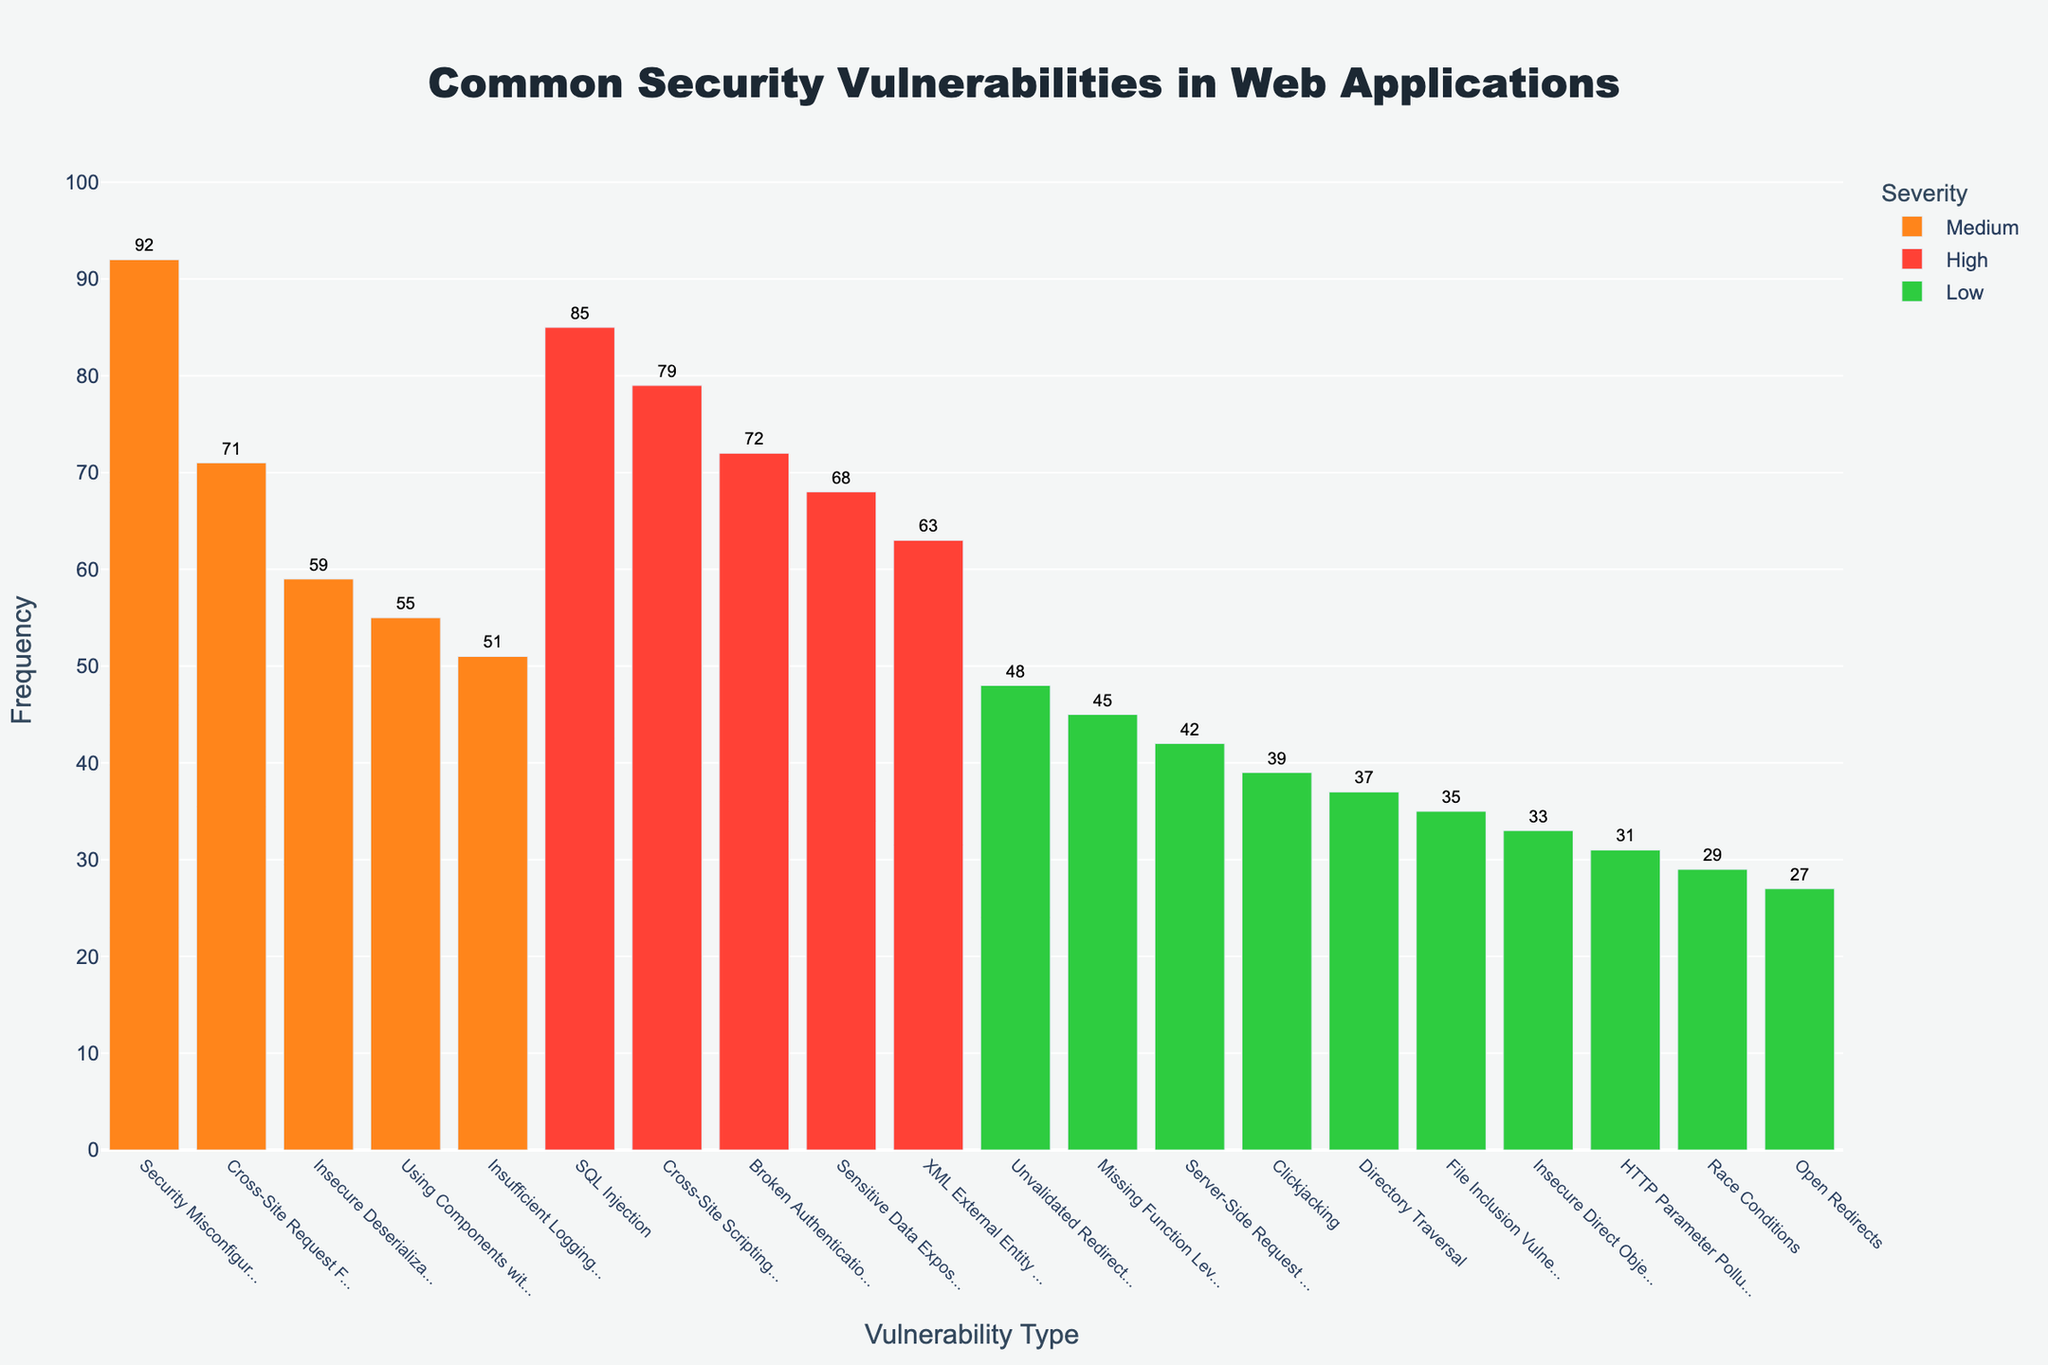Which vulnerability has the highest frequency? The bar at the farthest left, which is the tallest and marked in orange, represents 'Security Misconfiguration' in the Medium severity category with a frequency of 92.
Answer: Security Misconfiguration Which 'High' severity vulnerability has the lowest frequency? Among the red bars, 'XML External Entity (XXE)' is the shortest, indicating the lowest frequency among the 'High' severity vulnerabilities, with a frequency of 63.
Answer: XML External Entity (XXE) How does the frequency of 'Cross-Site Request Forgery (CSRF)' compare to 'Insecure Deserialization'? The bars for 'Cross-Site Request Forgery (CSRF)' and 'Insecure Deserialization' are both in the Medium severity category (orange). 'CSRF' bar is slightly taller with a frequency of 71, compared to 'Insecure Deserialization' with a frequency of 59.
Answer: CSRF has a higher frequency than Insecure Deserialization What is the total frequency of all 'Low' severity vulnerabilities? Sum the frequencies of all 'Low' severity vulnerabilities: 48 (Unvalidated Redirects and Forwards) + 45 (Missing Function Level Access Control) + 42 (Server-Side Request Forgery (SSRF)) + 39 (Clickjacking) + 37 (Directory Traversal) + 35 (File Inclusion Vulnerabilities) + 33 (Insecure Direct Object References (IDOR)) + 31 (HTTP Parameter Pollution) + 29 (Race Conditions) + 27 (Open Redirects). Doing the math: 48+45+42+39+37+35+33+31+29+27 = 366.
Answer: 366 What is the average frequency of 'High' severity vulnerabilities? Sum the frequencies of 'High' severity vulnerabilities (85, 79, 72, 68, 63). There are 5 items, so divide the sum by 5: (85 + 79 + 72 + 68 + 63) = 367 / 5 = 73.4
Answer: 73.4 Compare the frequency of 'SQL Injection' to the combined frequency of 'File Inclusion Vulnerabilities' and 'Directory Traversal'. 'SQL Injection' (red bar) has a frequency of 85. Sum 'File Inclusion Vulnerabilities' (frequency 35, green bar) and 'Directory Traversal' (frequency 37, green bar): 35 + 37 = 72. SQL Injection (85) compared to 72 is higher.
Answer: SQL Injection has a higher frequency than the combined frequency of the other two Which vulnerability type has the lowest frequency overall? The smallest (green) bar labeled 'Open Redirects' in the Low severity category has the lowest frequency of 27.
Answer: Open Redirects How many more occurrences does 'Security Misconfiguration' have compared to 'Insufficient Logging & Monitoring'? The frequency of 'Security Misconfiguration' (Medium severity, orange bar) is 92, and 'Insufficient Logging & Monitoring' (also Medium severity, orange bar) is 51. The difference is 92 - 51 = 41.
Answer: 41 What percentage of the total frequency do 'High' severity vulnerabilities account for? Sum the frequencies of 'High' severity vulnerabilities: 85 + 79 + 72 + 68 + 63 = 367. Calculate total frequency of all vulnerabilities (sum all frequencies): 92+71+59+55+51+48+45+42+39+37+35+33+31+29+27 = 795 + 367 = 1162. Calculate 367 / 1162 * 100 = 31.57%.
Answer: 31.57% 